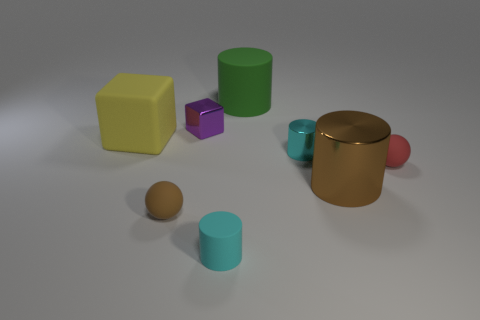Add 1 brown cylinders. How many objects exist? 9 Subtract all spheres. How many objects are left? 6 Subtract all cyan metal cylinders. Subtract all small rubber balls. How many objects are left? 5 Add 4 tiny cyan things. How many tiny cyan things are left? 6 Add 3 small cyan metal objects. How many small cyan metal objects exist? 4 Subtract 0 purple balls. How many objects are left? 8 